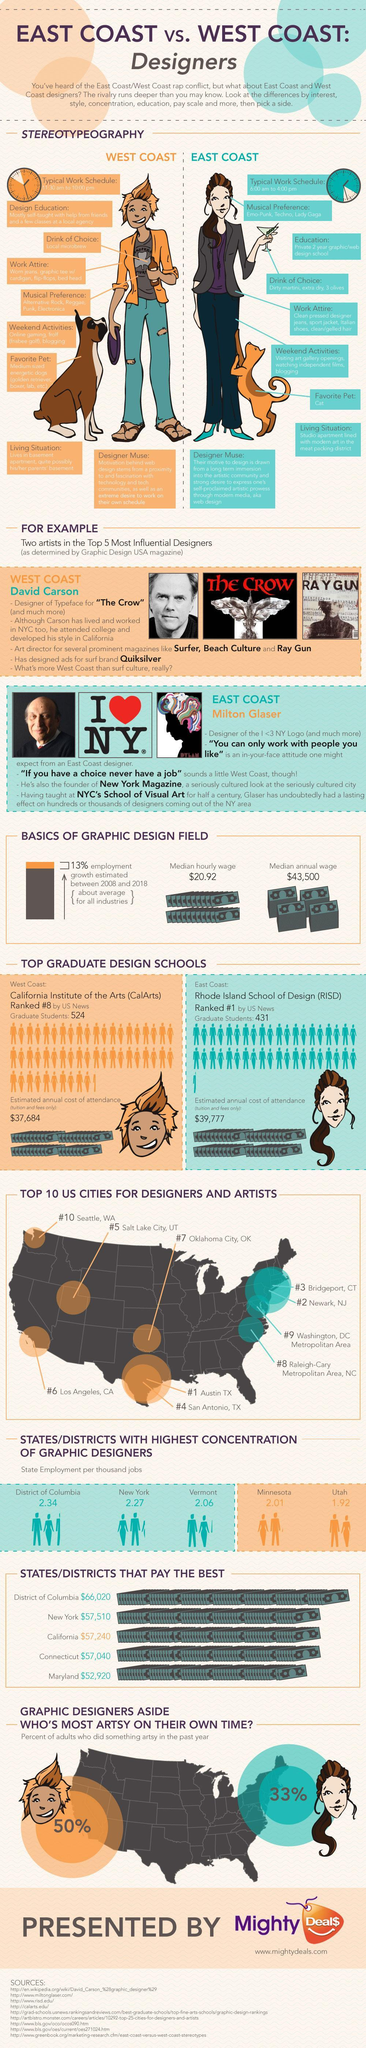What is the percentage of adults who did not something artsy for East Coast in the last year?
Answer the question with a short phrase. 67% How much is the median annual wage 43,500 How many aspects of the East Coast and West Coast designers are taken for comparison in the info graphic? 7 Which is the second highest state concentrated with graphic designers New York What is the inverse of the employment growth calculated in the period 2008 to 2018 ? 87% How much is the calculated annual cost of attendance for the East Coast $39,777 How much is the median hourly wage? 20.92 Name the school which is ranked first by the US news Rhode Island School of Design How many students have been graduated from the Rhode Island School of Design 431 How many graphic designers are employed in the state of Utah 1.92 